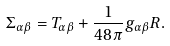Convert formula to latex. <formula><loc_0><loc_0><loc_500><loc_500>\Sigma _ { \alpha \beta } = T _ { \alpha \beta } + \frac { 1 } { 4 8 \pi } g _ { \alpha \beta } R .</formula> 